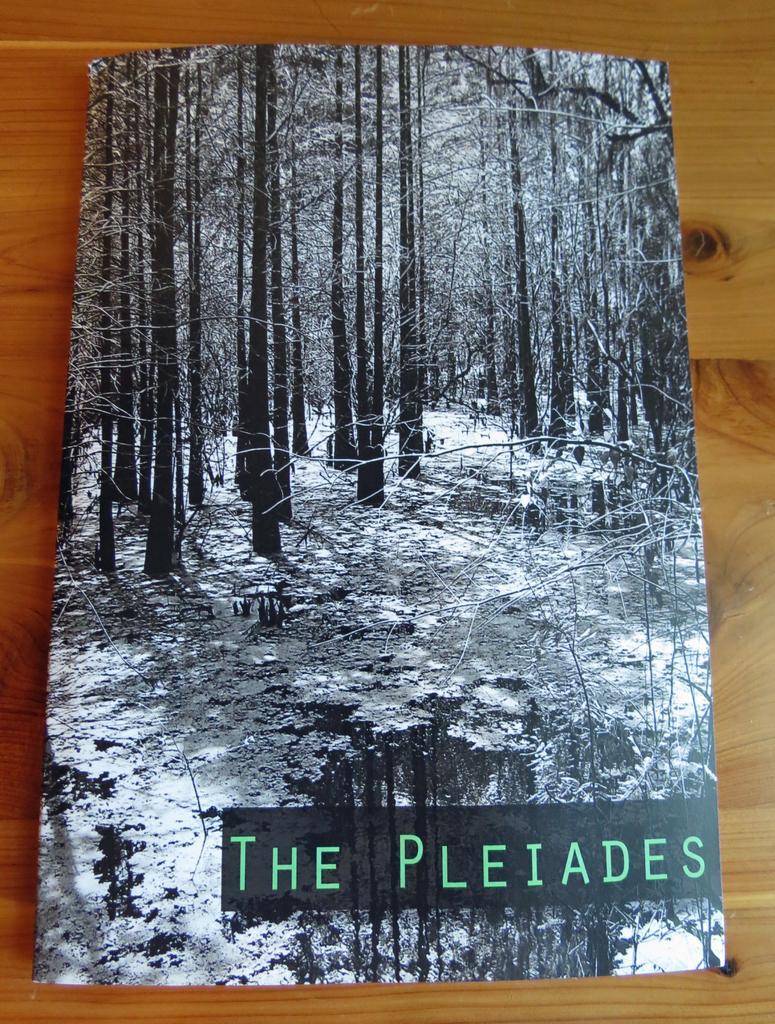Describe this image in one or two sentences. In this image there is a book on the wooden table. On the book there are pictures and text. There are pictures of the trees on the book. 